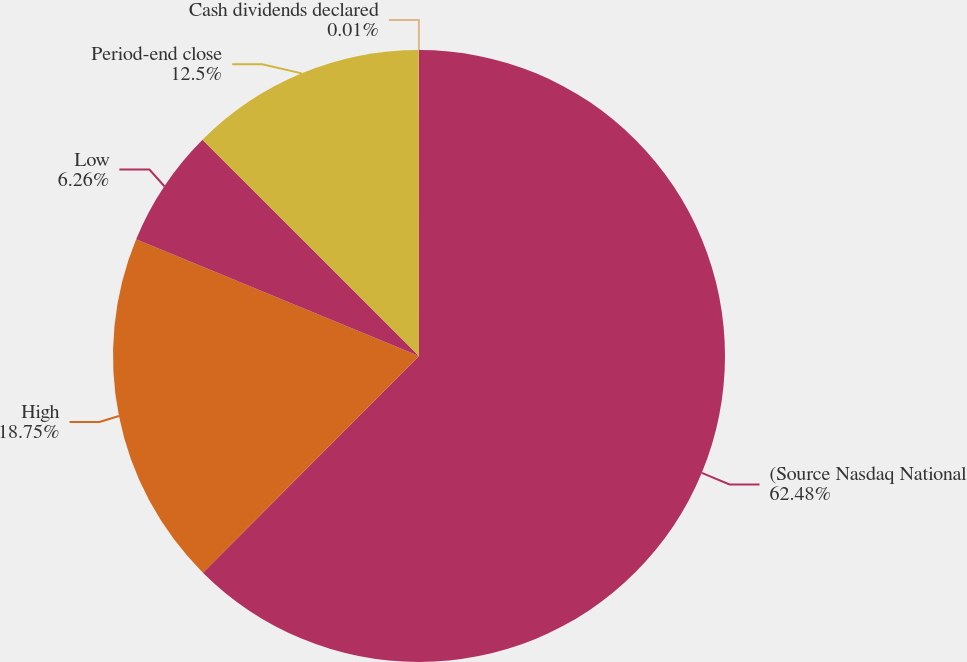Convert chart to OTSL. <chart><loc_0><loc_0><loc_500><loc_500><pie_chart><fcel>(Source Nasdaq National<fcel>High<fcel>Low<fcel>Period-end close<fcel>Cash dividends declared<nl><fcel>62.48%<fcel>18.75%<fcel>6.26%<fcel>12.5%<fcel>0.01%<nl></chart> 